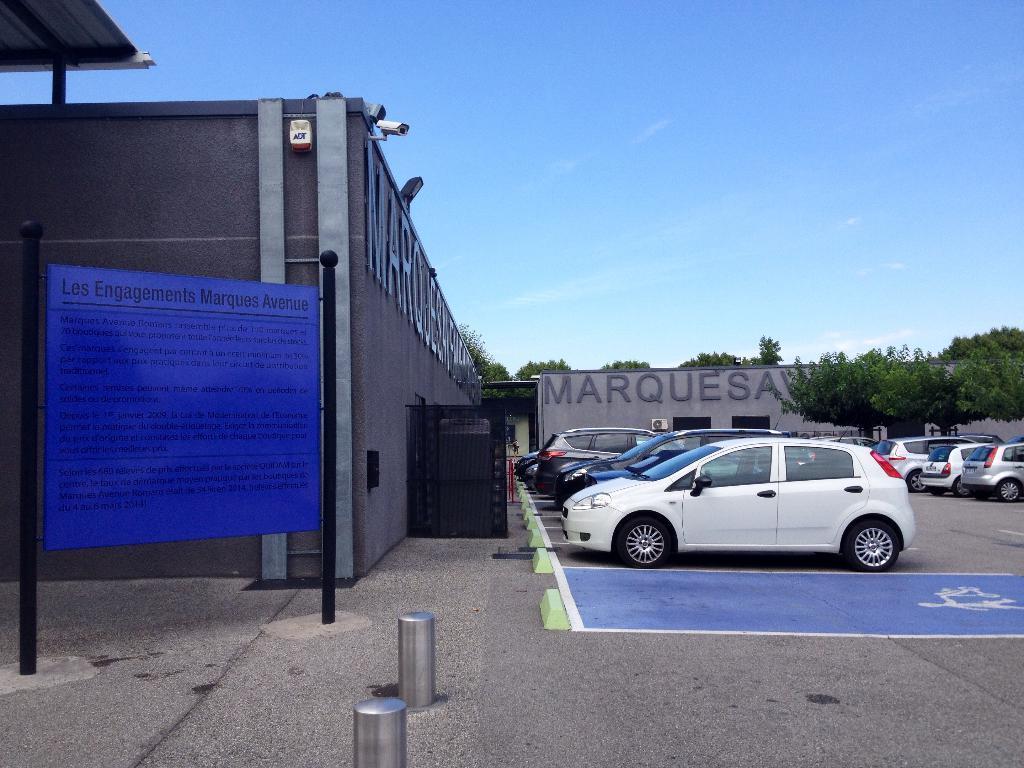Can you describe this image briefly? In this image we can see group of cars placed in a parking lot. In the background we can see group of buildings ,a sign board,poles ,trees and sky. 